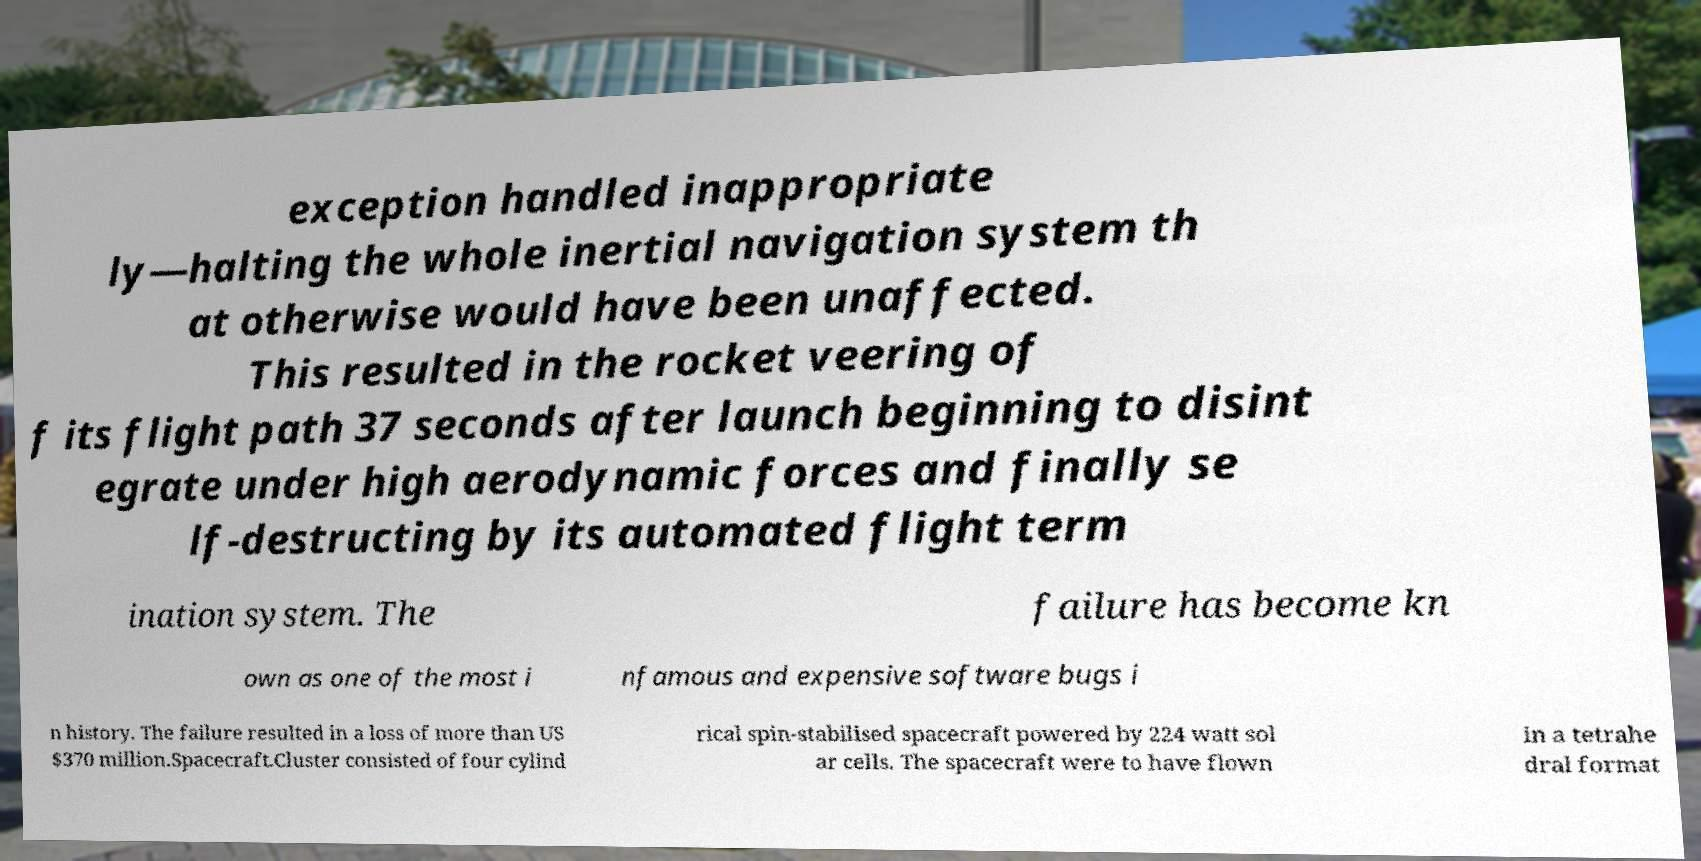Please read and relay the text visible in this image. What does it say? exception handled inappropriate ly—halting the whole inertial navigation system th at otherwise would have been unaffected. This resulted in the rocket veering of f its flight path 37 seconds after launch beginning to disint egrate under high aerodynamic forces and finally se lf-destructing by its automated flight term ination system. The failure has become kn own as one of the most i nfamous and expensive software bugs i n history. The failure resulted in a loss of more than US $370 million.Spacecraft.Cluster consisted of four cylind rical spin-stabilised spacecraft powered by 224 watt sol ar cells. The spacecraft were to have flown in a tetrahe dral format 